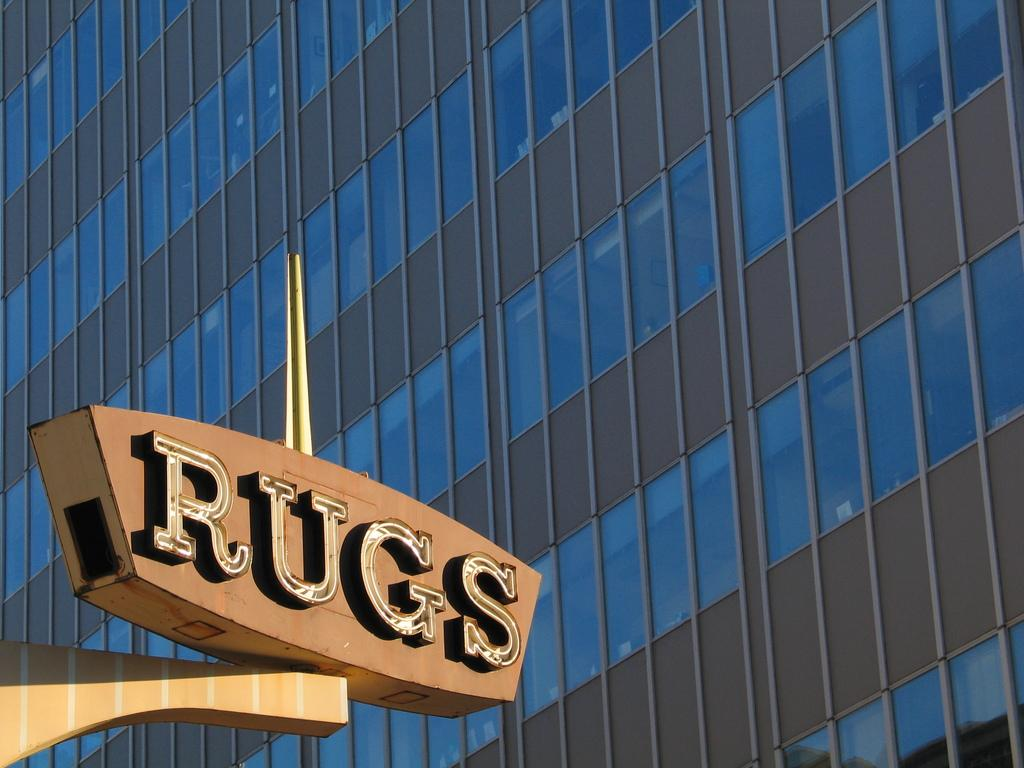What type of building is visible in the image? There is a building with glass windows in the image. Where is the building located in the image? The building is on the right side of the image. What is on the left side of the image? There is a board on the left side of the image. How many apples are being crushed by the building in the image? There are no apples or any indication of crushing in the image. 